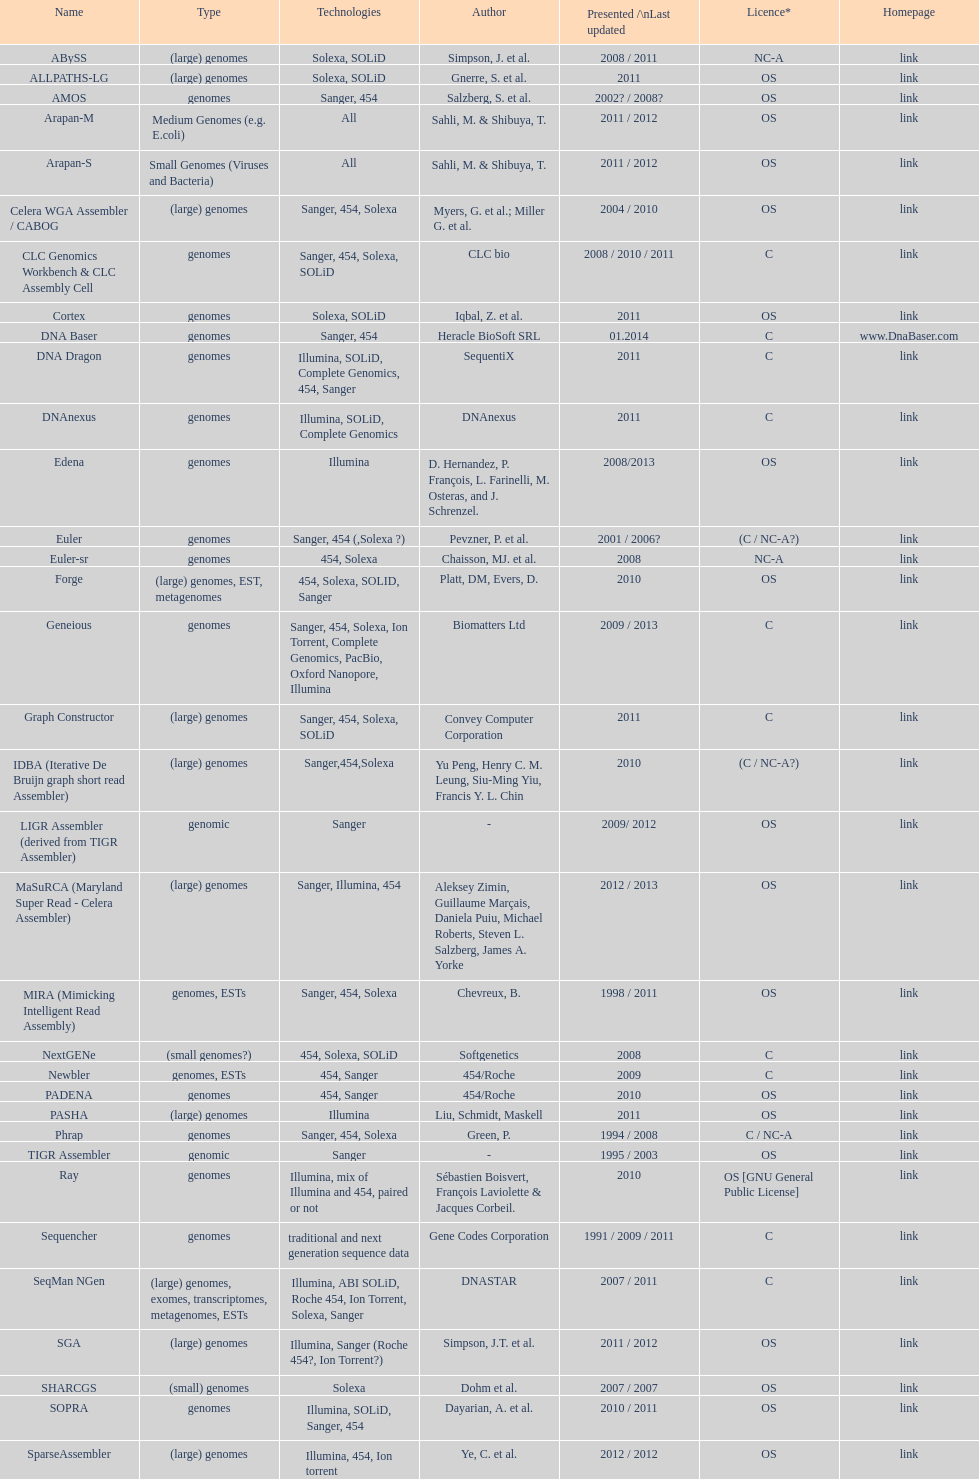Could you parse the entire table as a dict? {'header': ['Name', 'Type', 'Technologies', 'Author', 'Presented /\\nLast updated', 'Licence*', 'Homepage'], 'rows': [['ABySS', '(large) genomes', 'Solexa, SOLiD', 'Simpson, J. et al.', '2008 / 2011', 'NC-A', 'link'], ['ALLPATHS-LG', '(large) genomes', 'Solexa, SOLiD', 'Gnerre, S. et al.', '2011', 'OS', 'link'], ['AMOS', 'genomes', 'Sanger, 454', 'Salzberg, S. et al.', '2002? / 2008?', 'OS', 'link'], ['Arapan-M', 'Medium Genomes (e.g. E.coli)', 'All', 'Sahli, M. & Shibuya, T.', '2011 / 2012', 'OS', 'link'], ['Arapan-S', 'Small Genomes (Viruses and Bacteria)', 'All', 'Sahli, M. & Shibuya, T.', '2011 / 2012', 'OS', 'link'], ['Celera WGA Assembler / CABOG', '(large) genomes', 'Sanger, 454, Solexa', 'Myers, G. et al.; Miller G. et al.', '2004 / 2010', 'OS', 'link'], ['CLC Genomics Workbench & CLC Assembly Cell', 'genomes', 'Sanger, 454, Solexa, SOLiD', 'CLC bio', '2008 / 2010 / 2011', 'C', 'link'], ['Cortex', 'genomes', 'Solexa, SOLiD', 'Iqbal, Z. et al.', '2011', 'OS', 'link'], ['DNA Baser', 'genomes', 'Sanger, 454', 'Heracle BioSoft SRL', '01.2014', 'C', 'www.DnaBaser.com'], ['DNA Dragon', 'genomes', 'Illumina, SOLiD, Complete Genomics, 454, Sanger', 'SequentiX', '2011', 'C', 'link'], ['DNAnexus', 'genomes', 'Illumina, SOLiD, Complete Genomics', 'DNAnexus', '2011', 'C', 'link'], ['Edena', 'genomes', 'Illumina', 'D. Hernandez, P. François, L. Farinelli, M. Osteras, and J. Schrenzel.', '2008/2013', 'OS', 'link'], ['Euler', 'genomes', 'Sanger, 454 (,Solexa\xa0?)', 'Pevzner, P. et al.', '2001 / 2006?', '(C / NC-A?)', 'link'], ['Euler-sr', 'genomes', '454, Solexa', 'Chaisson, MJ. et al.', '2008', 'NC-A', 'link'], ['Forge', '(large) genomes, EST, metagenomes', '454, Solexa, SOLID, Sanger', 'Platt, DM, Evers, D.', '2010', 'OS', 'link'], ['Geneious', 'genomes', 'Sanger, 454, Solexa, Ion Torrent, Complete Genomics, PacBio, Oxford Nanopore, Illumina', 'Biomatters Ltd', '2009 / 2013', 'C', 'link'], ['Graph Constructor', '(large) genomes', 'Sanger, 454, Solexa, SOLiD', 'Convey Computer Corporation', '2011', 'C', 'link'], ['IDBA (Iterative De Bruijn graph short read Assembler)', '(large) genomes', 'Sanger,454,Solexa', 'Yu Peng, Henry C. M. Leung, Siu-Ming Yiu, Francis Y. L. Chin', '2010', '(C / NC-A?)', 'link'], ['LIGR Assembler (derived from TIGR Assembler)', 'genomic', 'Sanger', '-', '2009/ 2012', 'OS', 'link'], ['MaSuRCA (Maryland Super Read - Celera Assembler)', '(large) genomes', 'Sanger, Illumina, 454', 'Aleksey Zimin, Guillaume Marçais, Daniela Puiu, Michael Roberts, Steven L. Salzberg, James A. Yorke', '2012 / 2013', 'OS', 'link'], ['MIRA (Mimicking Intelligent Read Assembly)', 'genomes, ESTs', 'Sanger, 454, Solexa', 'Chevreux, B.', '1998 / 2011', 'OS', 'link'], ['NextGENe', '(small genomes?)', '454, Solexa, SOLiD', 'Softgenetics', '2008', 'C', 'link'], ['Newbler', 'genomes, ESTs', '454, Sanger', '454/Roche', '2009', 'C', 'link'], ['PADENA', 'genomes', '454, Sanger', '454/Roche', '2010', 'OS', 'link'], ['PASHA', '(large) genomes', 'Illumina', 'Liu, Schmidt, Maskell', '2011', 'OS', 'link'], ['Phrap', 'genomes', 'Sanger, 454, Solexa', 'Green, P.', '1994 / 2008', 'C / NC-A', 'link'], ['TIGR Assembler', 'genomic', 'Sanger', '-', '1995 / 2003', 'OS', 'link'], ['Ray', 'genomes', 'Illumina, mix of Illumina and 454, paired or not', 'Sébastien Boisvert, François Laviolette & Jacques Corbeil.', '2010', 'OS [GNU General Public License]', 'link'], ['Sequencher', 'genomes', 'traditional and next generation sequence data', 'Gene Codes Corporation', '1991 / 2009 / 2011', 'C', 'link'], ['SeqMan NGen', '(large) genomes, exomes, transcriptomes, metagenomes, ESTs', 'Illumina, ABI SOLiD, Roche 454, Ion Torrent, Solexa, Sanger', 'DNASTAR', '2007 / 2011', 'C', 'link'], ['SGA', '(large) genomes', 'Illumina, Sanger (Roche 454?, Ion Torrent?)', 'Simpson, J.T. et al.', '2011 / 2012', 'OS', 'link'], ['SHARCGS', '(small) genomes', 'Solexa', 'Dohm et al.', '2007 / 2007', 'OS', 'link'], ['SOPRA', 'genomes', 'Illumina, SOLiD, Sanger, 454', 'Dayarian, A. et al.', '2010 / 2011', 'OS', 'link'], ['SparseAssembler', '(large) genomes', 'Illumina, 454, Ion torrent', 'Ye, C. et al.', '2012 / 2012', 'OS', 'link'], ['SSAKE', '(small) genomes', 'Solexa (SOLiD? Helicos?)', 'Warren, R. et al.', '2007 / 2007', 'OS', 'link'], ['SOAPdenovo', 'genomes', 'Solexa', 'Li, R. et al.', '2009 / 2009', 'OS', 'link'], ['SPAdes', '(small) genomes, single-cell', 'Illumina, Solexa', 'Bankevich, A et al.', '2012 / 2013', 'OS', 'link'], ['Staden gap4 package', 'BACs (, small genomes?)', 'Sanger', 'Staden et al.', '1991 / 2008', 'OS', 'link'], ['Taipan', '(small) genomes', 'Illumina', 'Schmidt, B. et al.', '2009', 'OS', 'link'], ['VCAKE', '(small) genomes', 'Solexa (SOLiD?, Helicos?)', 'Jeck, W. et al.', '2007 / 2007', 'OS', 'link'], ['Phusion assembler', '(large) genomes', 'Sanger', 'Mullikin JC, et al.', '2003', 'OS', 'link'], ['Quality Value Guided SRA (QSRA)', 'genomes', 'Sanger, Solexa', 'Bryant DW, et al.', '2009', 'OS', 'link'], ['Velvet', '(small) genomes', 'Sanger, 454, Solexa, SOLiD', 'Zerbino, D. et al.', '2007 / 2009', 'OS', 'link']]} What is the total number of assemblers supporting small genomes type technologies? 9. 